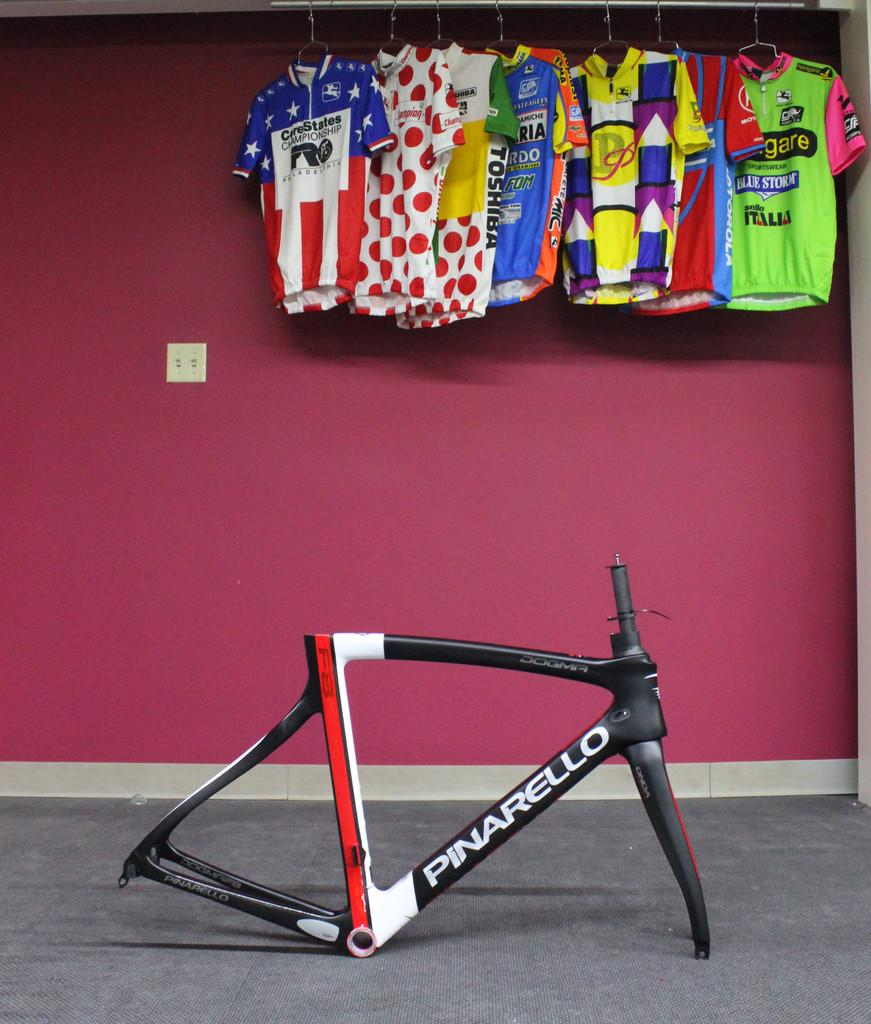<image>
Summarize the visual content of the image. A jersey that says CareStates Championship hangs against a pink wall 